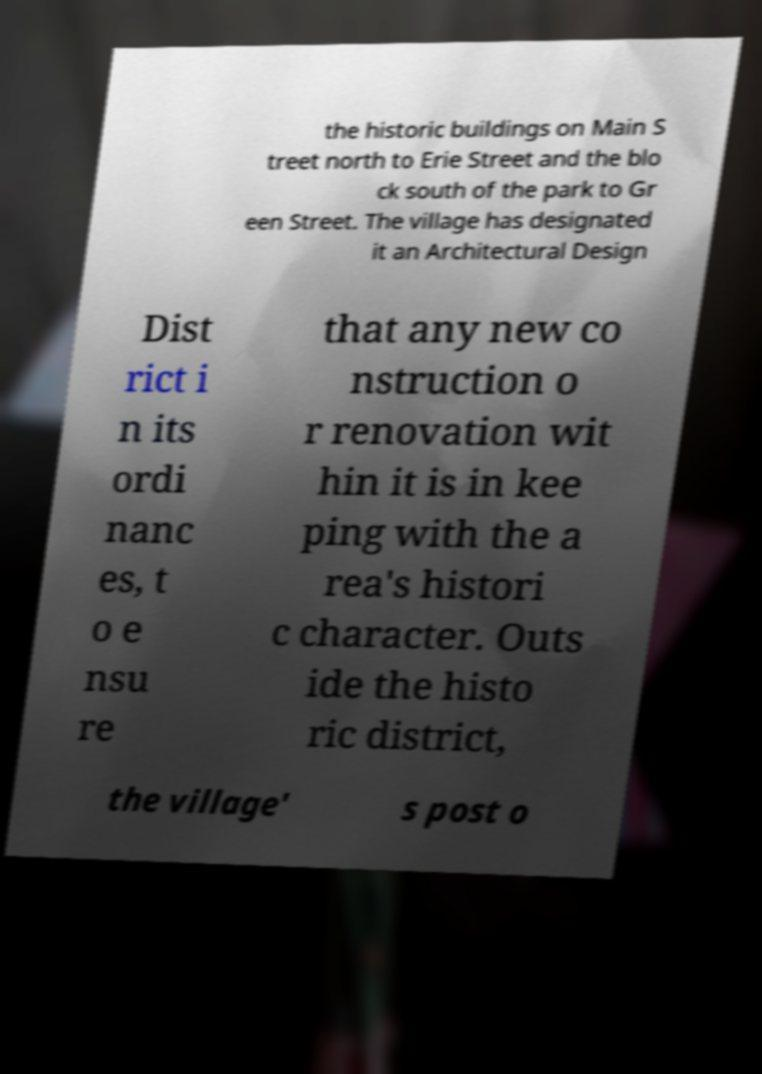Please identify and transcribe the text found in this image. the historic buildings on Main S treet north to Erie Street and the blo ck south of the park to Gr een Street. The village has designated it an Architectural Design Dist rict i n its ordi nanc es, t o e nsu re that any new co nstruction o r renovation wit hin it is in kee ping with the a rea's histori c character. Outs ide the histo ric district, the village' s post o 